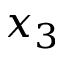Convert formula to latex. <formula><loc_0><loc_0><loc_500><loc_500>x _ { 3 }</formula> 